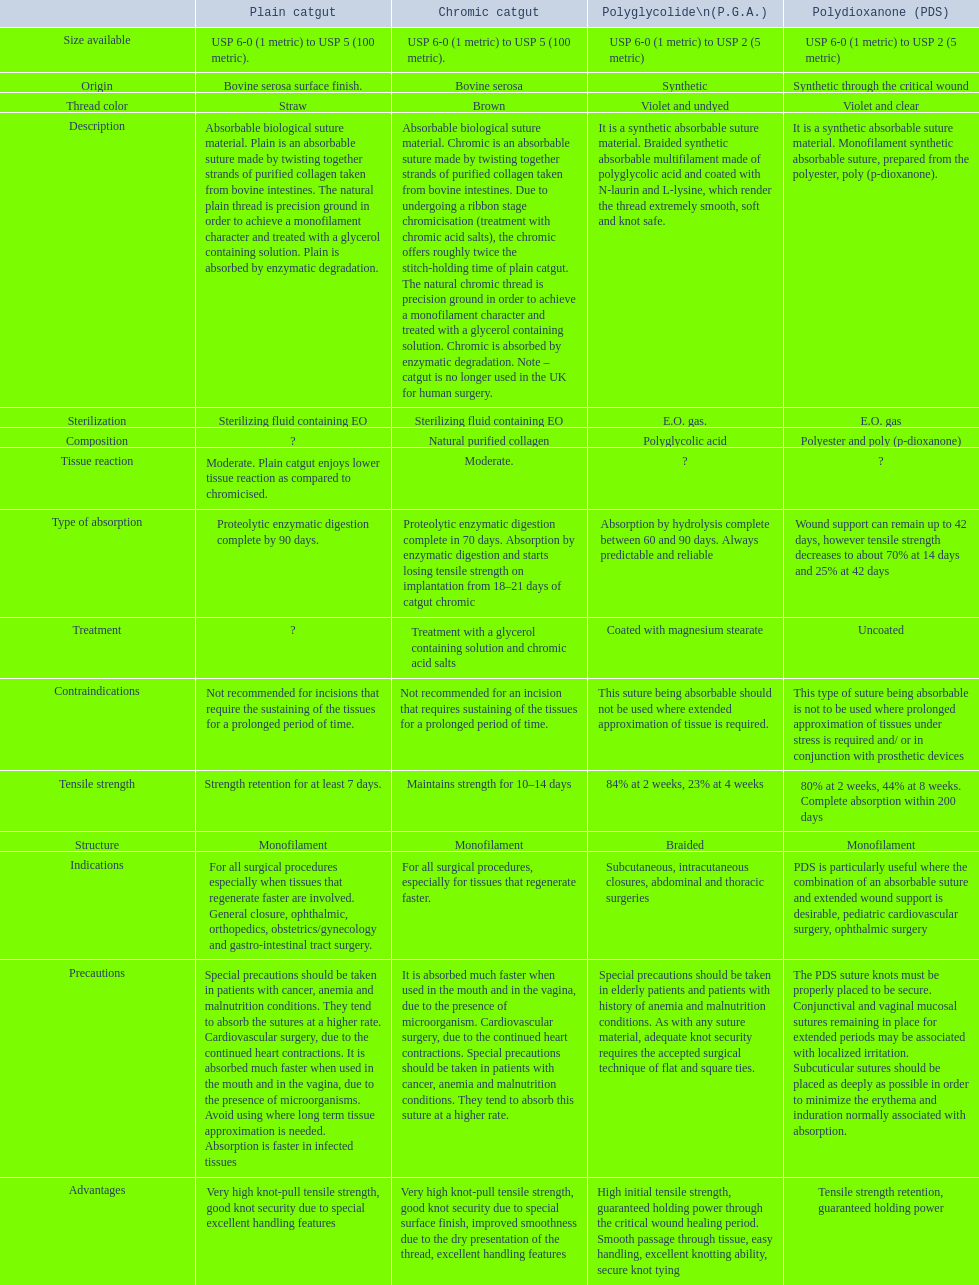What categories are listed in the suture materials comparison chart? Description, Composition, Tensile strength, Structure, Origin, Treatment, Type of absorption, Tissue reaction, Thread color, Size available, Sterilization, Advantages, Indications, Contraindications, Precautions. Of the testile strength, which is the lowest? Strength retention for at least 7 days. 